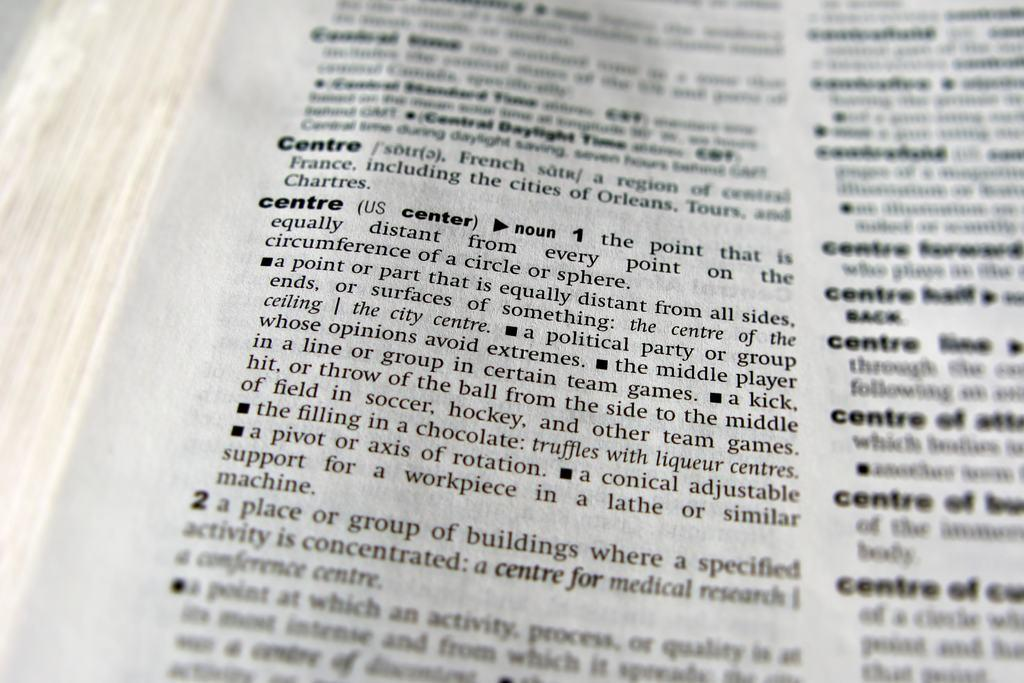<image>
Give a short and clear explanation of the subsequent image. the word centre is in a book with many words 